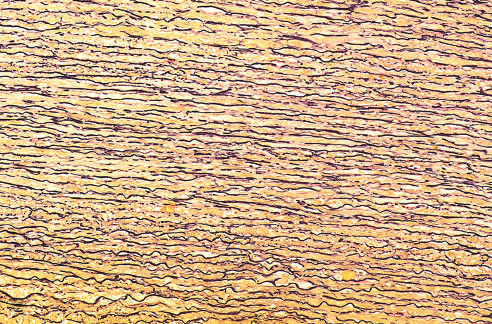s elastin stained black in the figure?
Answer the question using a single word or phrase. Yes 